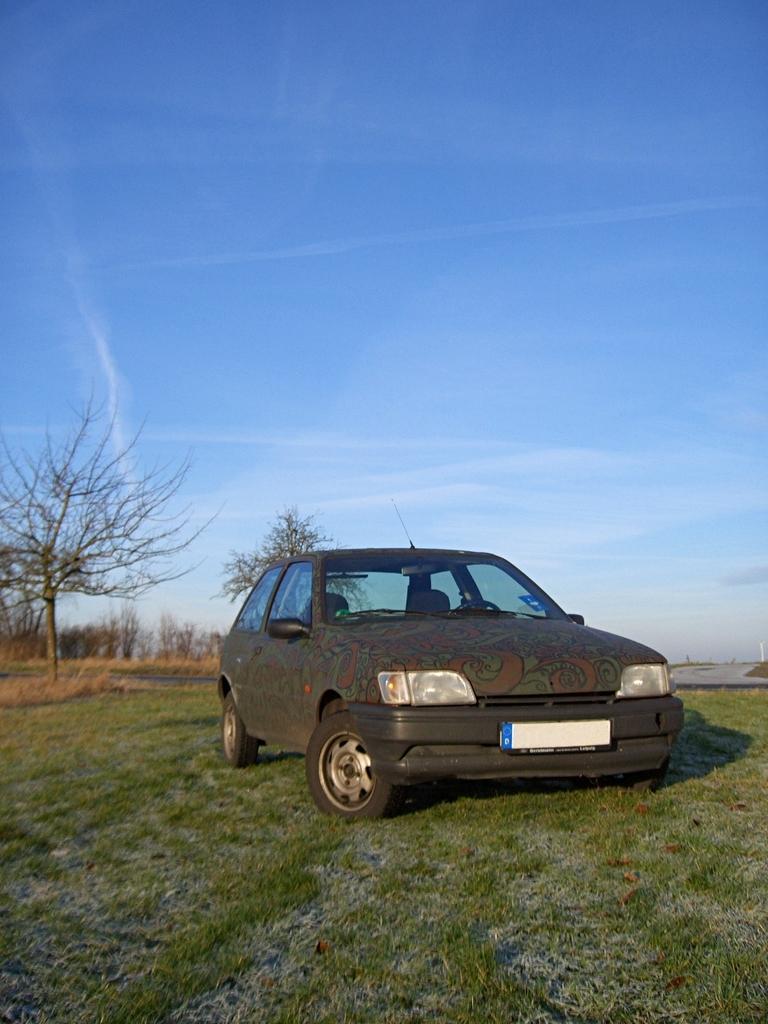How would you summarize this image in a sentence or two? In this image there is a car in the foreground. There is a green grass at the bottom. There are trees and dry grass in the background. And there is a sky at the top. 